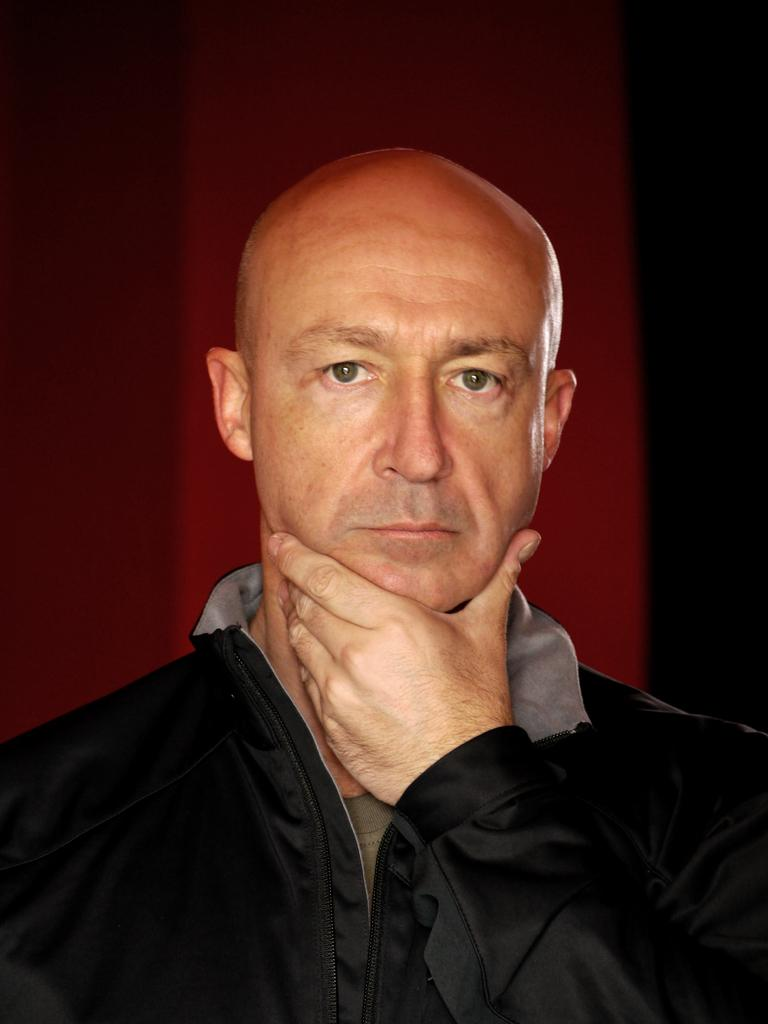What is the main subject of the image? There is a person in the image. What is the person doing in the image? The person is watching. What color is the background of the image? The background of the image has a maroon color. How would you describe the lighting in the background of the image? The view in the background is dark. What type of mine can be seen in the background of the image? There is no mine present in the image. What is the person using as a calculator in the image? There is no calculator present in the image. 